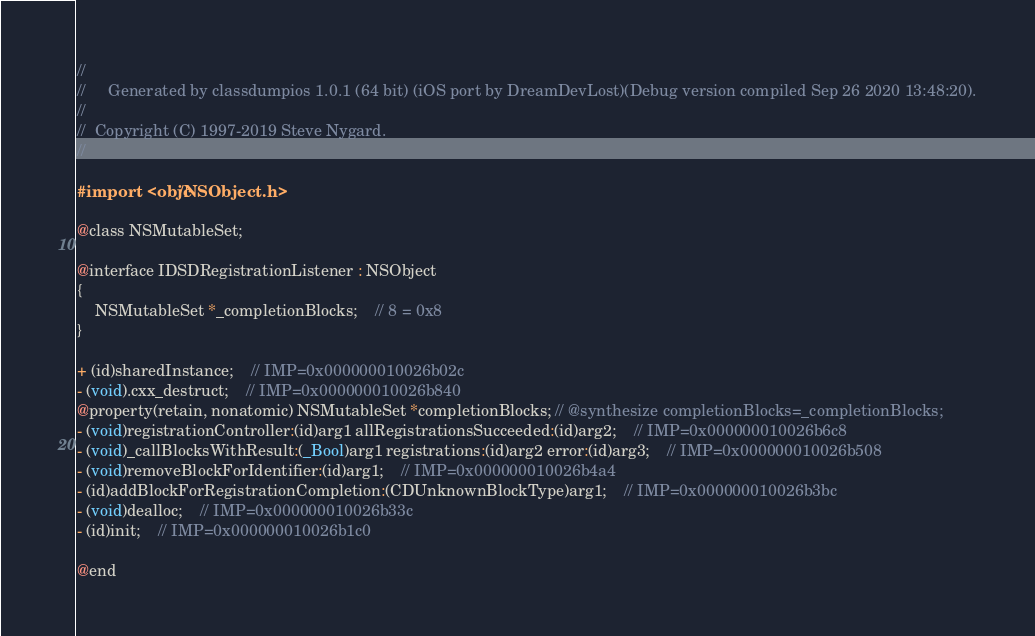Convert code to text. <code><loc_0><loc_0><loc_500><loc_500><_C_>//
//     Generated by classdumpios 1.0.1 (64 bit) (iOS port by DreamDevLost)(Debug version compiled Sep 26 2020 13:48:20).
//
//  Copyright (C) 1997-2019 Steve Nygard.
//

#import <objc/NSObject.h>

@class NSMutableSet;

@interface IDSDRegistrationListener : NSObject
{
    NSMutableSet *_completionBlocks;	// 8 = 0x8
}

+ (id)sharedInstance;	// IMP=0x000000010026b02c
- (void).cxx_destruct;	// IMP=0x000000010026b840
@property(retain, nonatomic) NSMutableSet *completionBlocks; // @synthesize completionBlocks=_completionBlocks;
- (void)registrationController:(id)arg1 allRegistrationsSucceeded:(id)arg2;	// IMP=0x000000010026b6c8
- (void)_callBlocksWithResult:(_Bool)arg1 registrations:(id)arg2 error:(id)arg3;	// IMP=0x000000010026b508
- (void)removeBlockForIdentifier:(id)arg1;	// IMP=0x000000010026b4a4
- (id)addBlockForRegistrationCompletion:(CDUnknownBlockType)arg1;	// IMP=0x000000010026b3bc
- (void)dealloc;	// IMP=0x000000010026b33c
- (id)init;	// IMP=0x000000010026b1c0

@end

</code> 